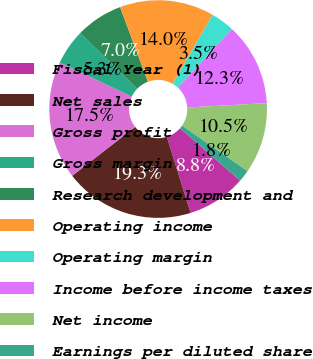Convert chart to OTSL. <chart><loc_0><loc_0><loc_500><loc_500><pie_chart><fcel>Fiscal Year (1)<fcel>Net sales<fcel>Gross profit<fcel>Gross margin<fcel>Research development and<fcel>Operating income<fcel>Operating margin<fcel>Income before income taxes<fcel>Net income<fcel>Earnings per diluted share<nl><fcel>8.77%<fcel>19.3%<fcel>17.54%<fcel>5.26%<fcel>7.02%<fcel>14.03%<fcel>3.51%<fcel>12.28%<fcel>10.53%<fcel>1.75%<nl></chart> 